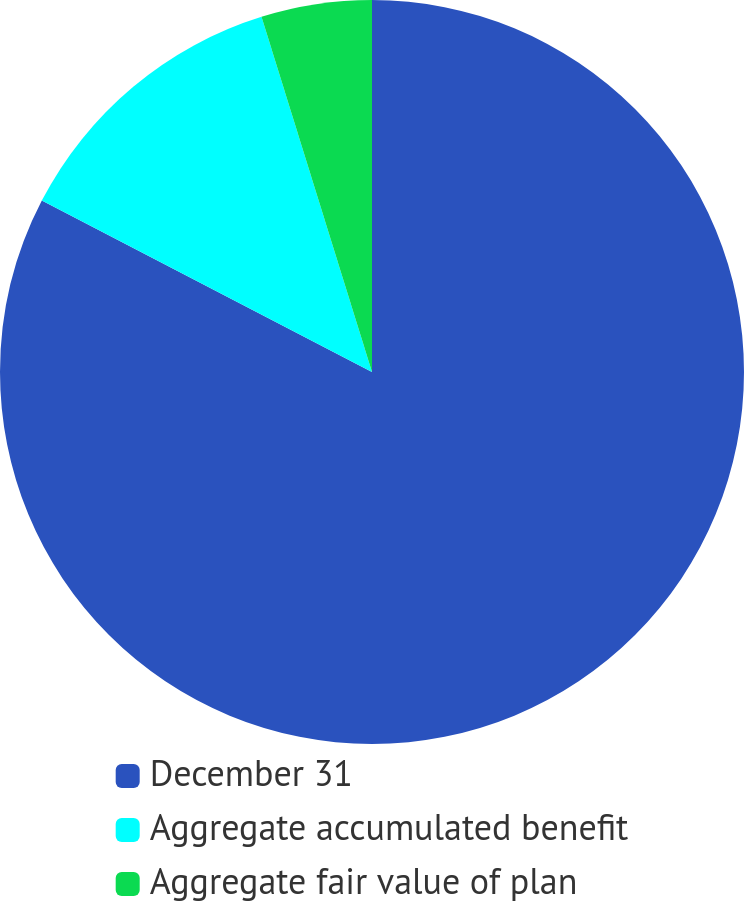<chart> <loc_0><loc_0><loc_500><loc_500><pie_chart><fcel>December 31<fcel>Aggregate accumulated benefit<fcel>Aggregate fair value of plan<nl><fcel>82.62%<fcel>12.58%<fcel>4.8%<nl></chart> 